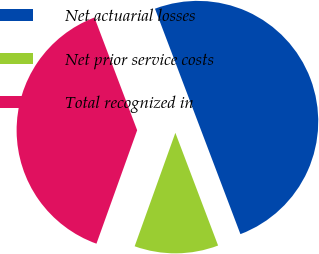Convert chart to OTSL. <chart><loc_0><loc_0><loc_500><loc_500><pie_chart><fcel>Net actuarial losses<fcel>Net prior service costs<fcel>Total recognized in<nl><fcel>50.0%<fcel>11.25%<fcel>38.75%<nl></chart> 